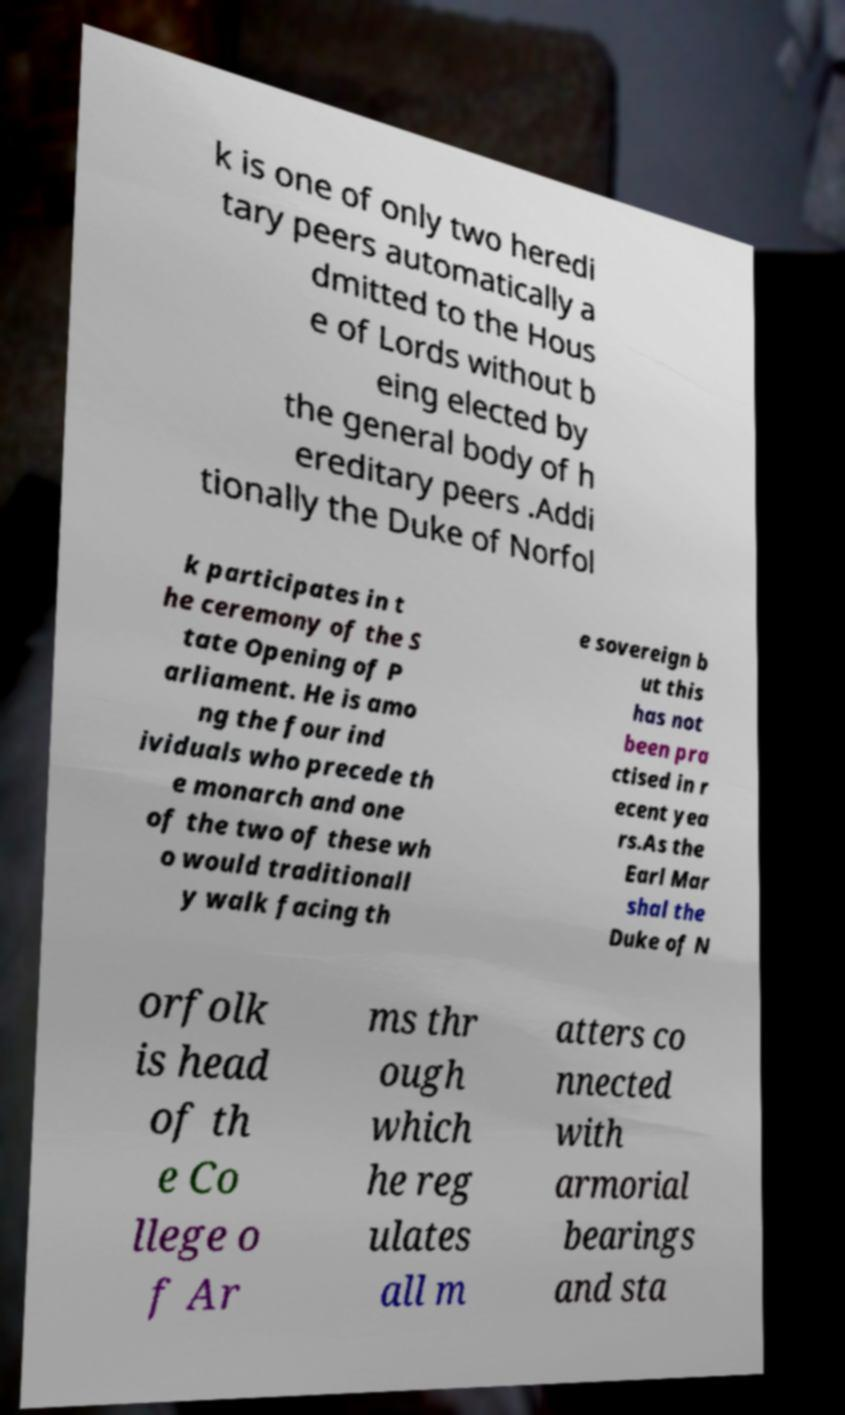For documentation purposes, I need the text within this image transcribed. Could you provide that? k is one of only two heredi tary peers automatically a dmitted to the Hous e of Lords without b eing elected by the general body of h ereditary peers .Addi tionally the Duke of Norfol k participates in t he ceremony of the S tate Opening of P arliament. He is amo ng the four ind ividuals who precede th e monarch and one of the two of these wh o would traditionall y walk facing th e sovereign b ut this has not been pra ctised in r ecent yea rs.As the Earl Mar shal the Duke of N orfolk is head of th e Co llege o f Ar ms thr ough which he reg ulates all m atters co nnected with armorial bearings and sta 